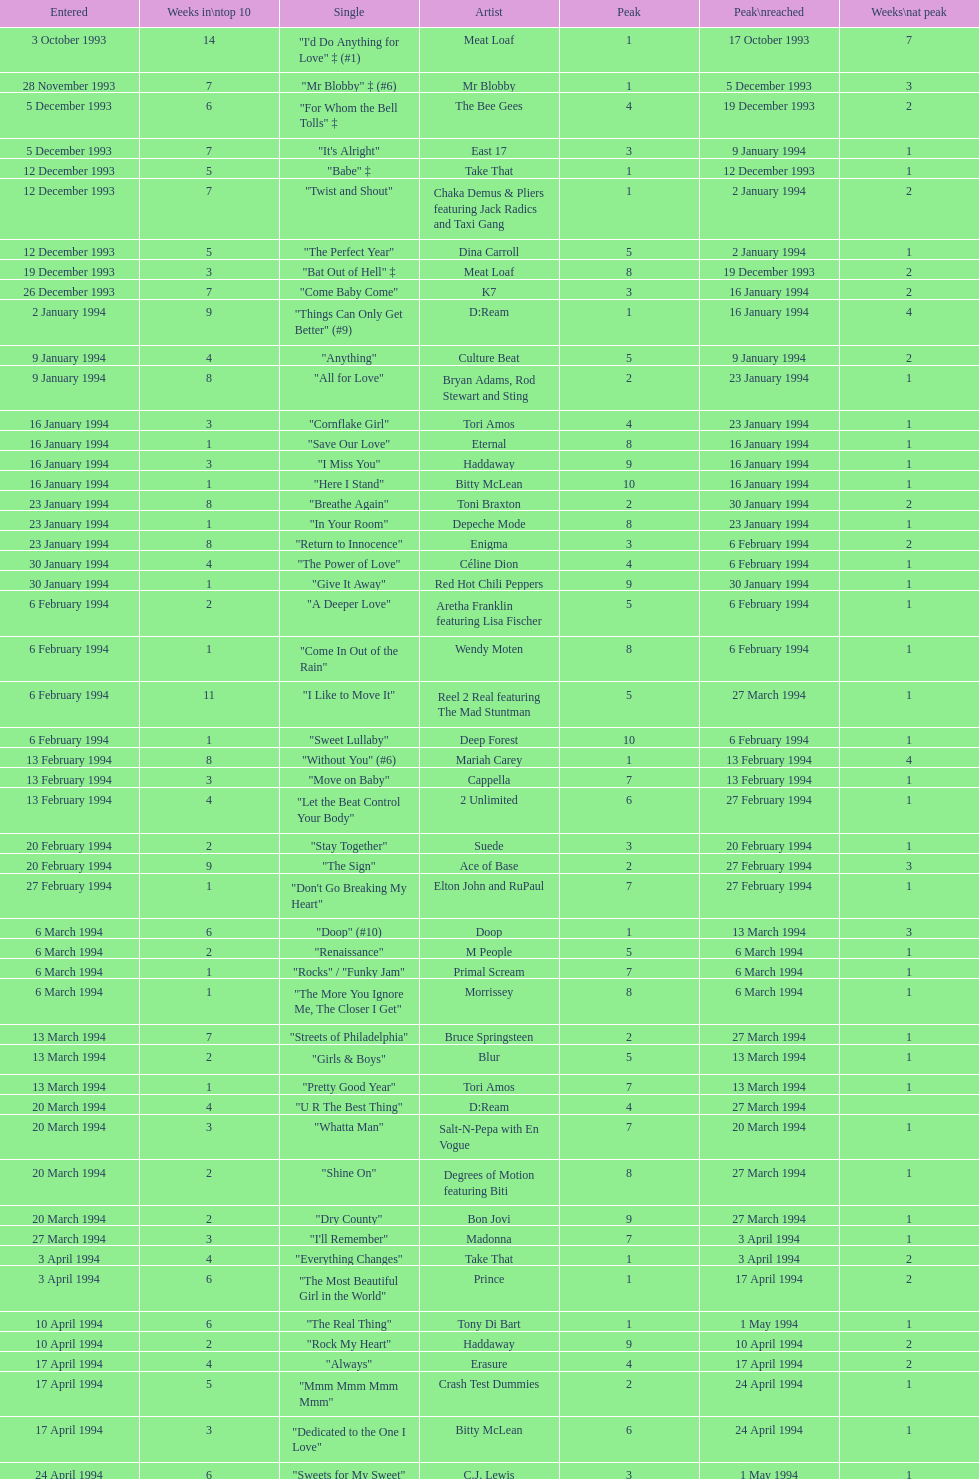Which date was entered first? 3 October 1993. 